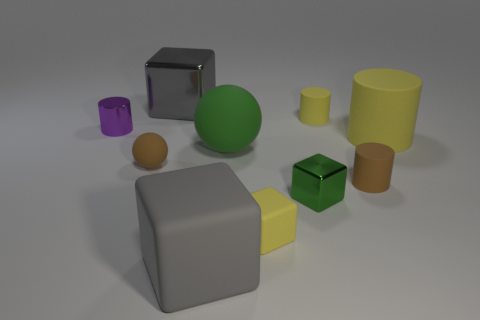Is there any other thing that has the same size as the green rubber object? There appears to be a yellow object that is cylindrical in shape and similar in size to the green rubber object. However, without exact measurements, it is difficult to confirm if they are exactly the same size. 